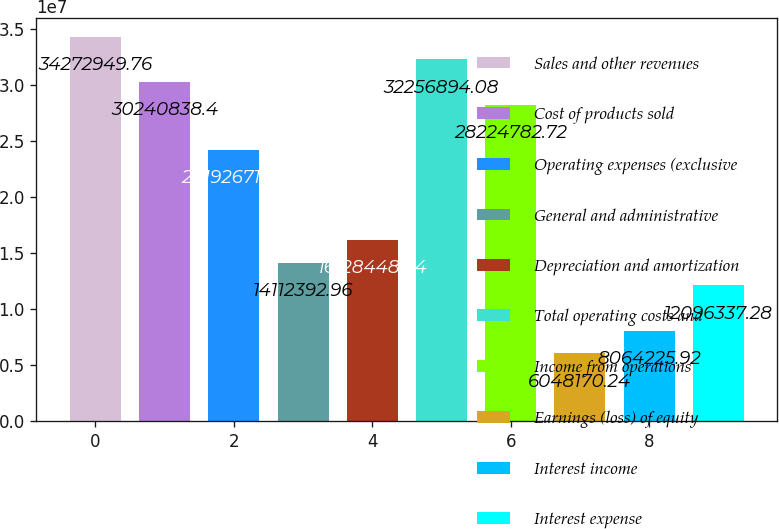Convert chart to OTSL. <chart><loc_0><loc_0><loc_500><loc_500><bar_chart><fcel>Sales and other revenues<fcel>Cost of products sold<fcel>Operating expenses (exclusive<fcel>General and administrative<fcel>Depreciation and amortization<fcel>Total operating costs and<fcel>Income from operations<fcel>Earnings (loss) of equity<fcel>Interest income<fcel>Interest expense<nl><fcel>3.42729e+07<fcel>3.02408e+07<fcel>2.41927e+07<fcel>1.41124e+07<fcel>1.61284e+07<fcel>3.22569e+07<fcel>2.82248e+07<fcel>6.04817e+06<fcel>8.06423e+06<fcel>1.20963e+07<nl></chart> 